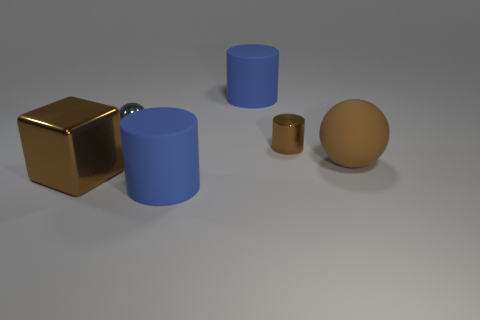Is there any other thing that has the same material as the small sphere?
Your response must be concise. Yes. Is there a brown cylinder of the same size as the gray object?
Offer a very short reply. Yes. There is a sphere that is behind the small metal cylinder; how many large brown metal cubes are behind it?
Give a very brief answer. 0. What material is the big brown sphere?
Offer a terse response. Rubber. There is a brown block; what number of tiny gray things are in front of it?
Provide a succinct answer. 0. Does the matte ball have the same color as the small cylinder?
Your response must be concise. Yes. What number of rubber objects are the same color as the large metal object?
Offer a very short reply. 1. Is the number of large matte cylinders greater than the number of large yellow objects?
Keep it short and to the point. Yes. How big is the brown thing that is left of the brown rubber object and to the right of the block?
Offer a very short reply. Small. Is the material of the large thing in front of the big brown cube the same as the ball that is on the left side of the small shiny cylinder?
Your response must be concise. No. 